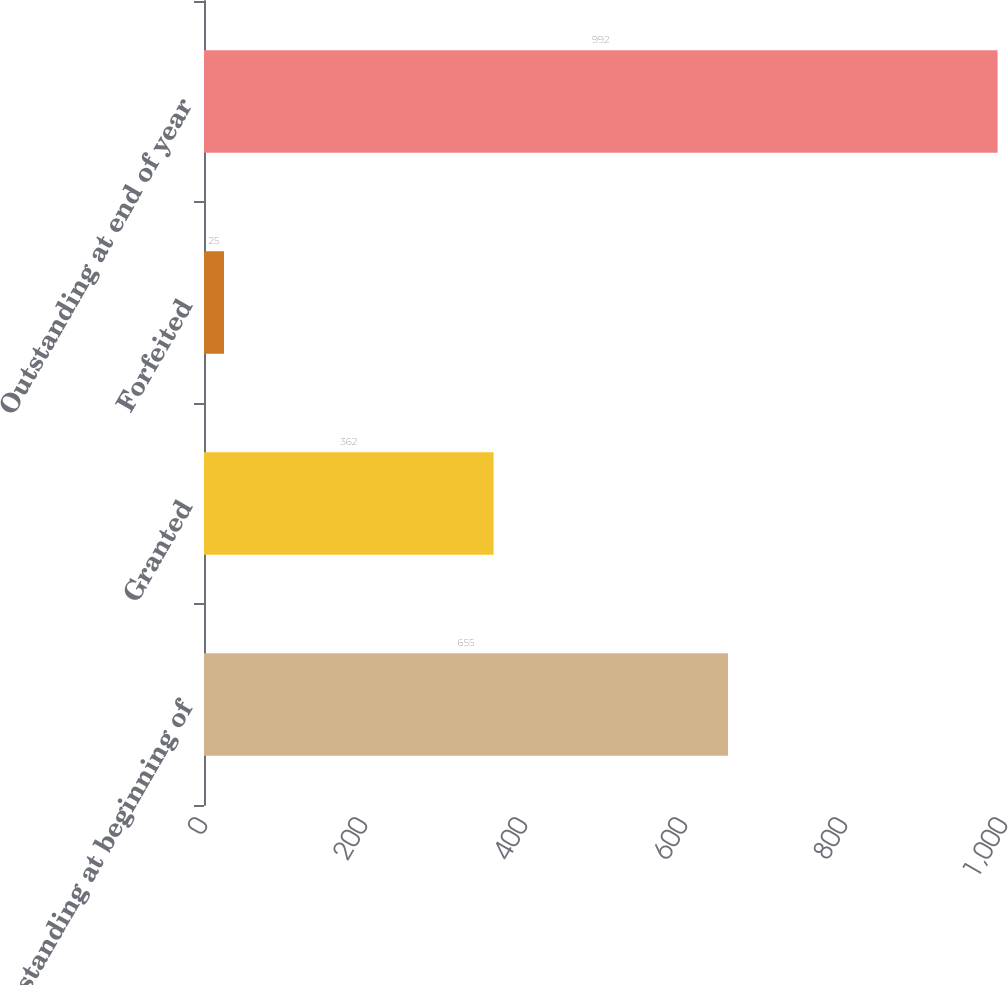Convert chart. <chart><loc_0><loc_0><loc_500><loc_500><bar_chart><fcel>Outstanding at beginning of<fcel>Granted<fcel>Forfeited<fcel>Outstanding at end of year<nl><fcel>655<fcel>362<fcel>25<fcel>992<nl></chart> 